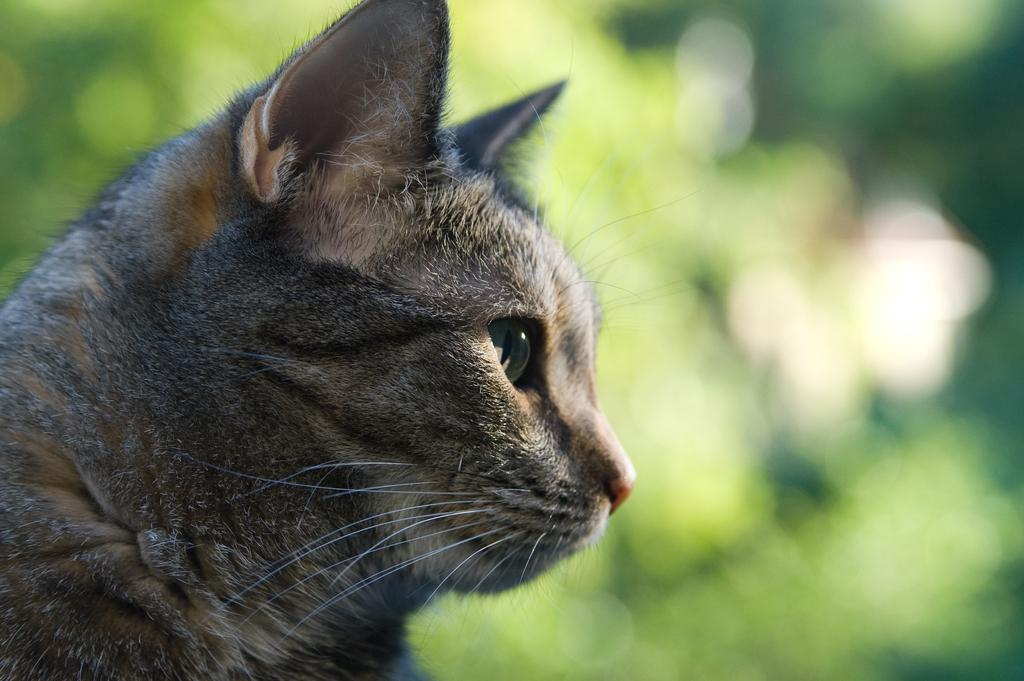What type of animal is in the picture? There is a cat in the picture. Can you describe the background of the picture? The background of the picture is blurry. What type of fowl can be seen in the picture? There is no fowl present in the picture; it features a cat. How many cows are visible in the picture? There are no cows visible in the picture; it features a cat. 